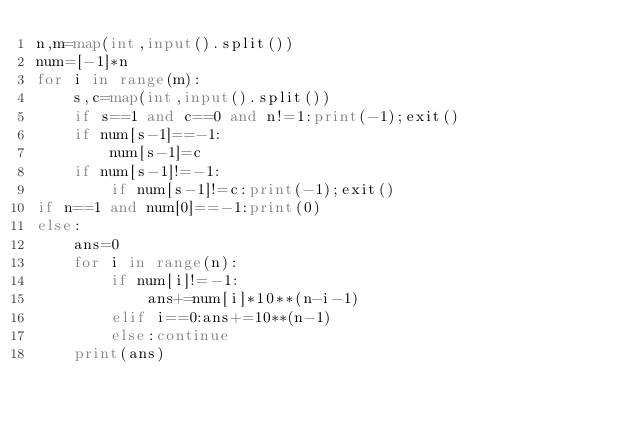<code> <loc_0><loc_0><loc_500><loc_500><_Python_>n,m=map(int,input().split())
num=[-1]*n
for i in range(m):
    s,c=map(int,input().split())
    if s==1 and c==0 and n!=1:print(-1);exit()
    if num[s-1]==-1:
        num[s-1]=c
    if num[s-1]!=-1:
        if num[s-1]!=c:print(-1);exit()
if n==1 and num[0]==-1:print(0)
else:
    ans=0
    for i in range(n):
        if num[i]!=-1:
            ans+=num[i]*10**(n-i-1)
        elif i==0:ans+=10**(n-1)
        else:continue
    print(ans)
    </code> 